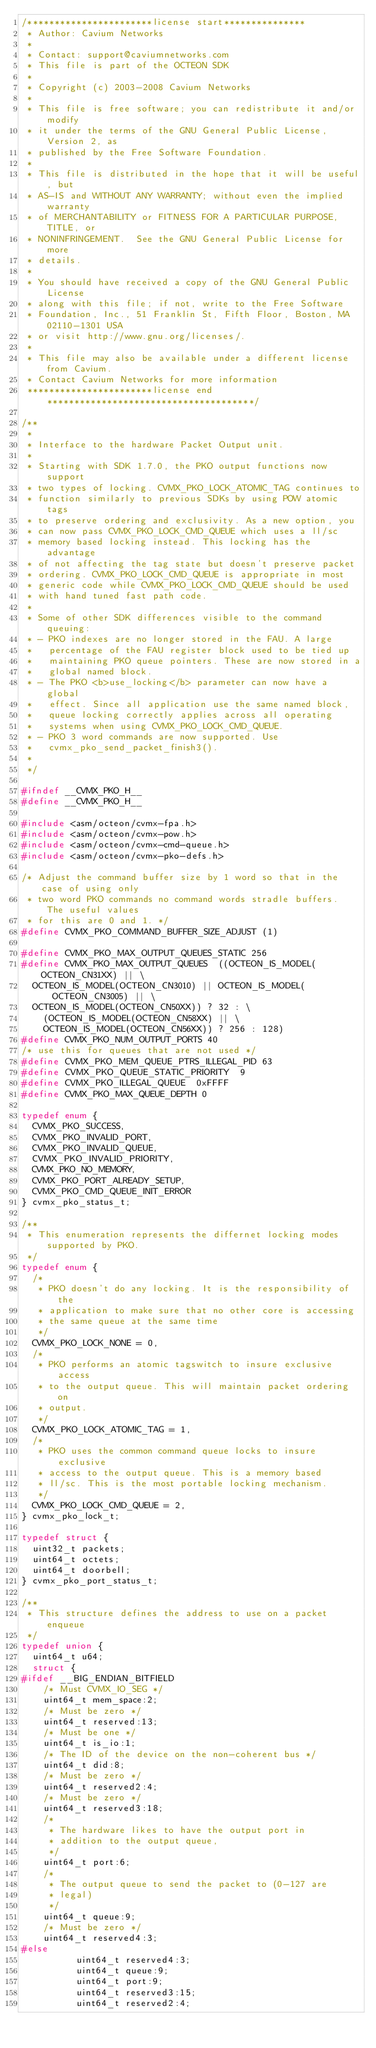<code> <loc_0><loc_0><loc_500><loc_500><_C_>/***********************license start***************
 * Author: Cavium Networks
 *
 * Contact: support@caviumnetworks.com
 * This file is part of the OCTEON SDK
 *
 * Copyright (c) 2003-2008 Cavium Networks
 *
 * This file is free software; you can redistribute it and/or modify
 * it under the terms of the GNU General Public License, Version 2, as
 * published by the Free Software Foundation.
 *
 * This file is distributed in the hope that it will be useful, but
 * AS-IS and WITHOUT ANY WARRANTY; without even the implied warranty
 * of MERCHANTABILITY or FITNESS FOR A PARTICULAR PURPOSE, TITLE, or
 * NONINFRINGEMENT.  See the GNU General Public License for more
 * details.
 *
 * You should have received a copy of the GNU General Public License
 * along with this file; if not, write to the Free Software
 * Foundation, Inc., 51 Franklin St, Fifth Floor, Boston, MA 02110-1301 USA
 * or visit http://www.gnu.org/licenses/.
 *
 * This file may also be available under a different license from Cavium.
 * Contact Cavium Networks for more information
 ***********************license end**************************************/

/**
 *
 * Interface to the hardware Packet Output unit.
 *
 * Starting with SDK 1.7.0, the PKO output functions now support
 * two types of locking. CVMX_PKO_LOCK_ATOMIC_TAG continues to
 * function similarly to previous SDKs by using POW atomic tags
 * to preserve ordering and exclusivity. As a new option, you
 * can now pass CVMX_PKO_LOCK_CMD_QUEUE which uses a ll/sc
 * memory based locking instead. This locking has the advantage
 * of not affecting the tag state but doesn't preserve packet
 * ordering. CVMX_PKO_LOCK_CMD_QUEUE is appropriate in most
 * generic code while CVMX_PKO_LOCK_CMD_QUEUE should be used
 * with hand tuned fast path code.
 *
 * Some of other SDK differences visible to the command queuing:
 * - PKO indexes are no longer stored in the FAU. A large
 *   percentage of the FAU register block used to be tied up
 *   maintaining PKO queue pointers. These are now stored in a
 *   global named block.
 * - The PKO <b>use_locking</b> parameter can now have a global
 *   effect. Since all application use the same named block,
 *   queue locking correctly applies across all operating
 *   systems when using CVMX_PKO_LOCK_CMD_QUEUE.
 * - PKO 3 word commands are now supported. Use
 *   cvmx_pko_send_packet_finish3().
 *
 */

#ifndef __CVMX_PKO_H__
#define __CVMX_PKO_H__

#include <asm/octeon/cvmx-fpa.h>
#include <asm/octeon/cvmx-pow.h>
#include <asm/octeon/cvmx-cmd-queue.h>
#include <asm/octeon/cvmx-pko-defs.h>

/* Adjust the command buffer size by 1 word so that in the case of using only
 * two word PKO commands no command words stradle buffers.  The useful values
 * for this are 0 and 1. */
#define CVMX_PKO_COMMAND_BUFFER_SIZE_ADJUST (1)

#define CVMX_PKO_MAX_OUTPUT_QUEUES_STATIC 256
#define CVMX_PKO_MAX_OUTPUT_QUEUES	((OCTEON_IS_MODEL(OCTEON_CN31XX) || \
	OCTEON_IS_MODEL(OCTEON_CN3010) || OCTEON_IS_MODEL(OCTEON_CN3005) || \
	OCTEON_IS_MODEL(OCTEON_CN50XX)) ? 32 : \
		(OCTEON_IS_MODEL(OCTEON_CN58XX) || \
		OCTEON_IS_MODEL(OCTEON_CN56XX)) ? 256 : 128)
#define CVMX_PKO_NUM_OUTPUT_PORTS	40
/* use this for queues that are not used */
#define CVMX_PKO_MEM_QUEUE_PTRS_ILLEGAL_PID 63
#define CVMX_PKO_QUEUE_STATIC_PRIORITY	9
#define CVMX_PKO_ILLEGAL_QUEUE	0xFFFF
#define CVMX_PKO_MAX_QUEUE_DEPTH 0

typedef enum {
	CVMX_PKO_SUCCESS,
	CVMX_PKO_INVALID_PORT,
	CVMX_PKO_INVALID_QUEUE,
	CVMX_PKO_INVALID_PRIORITY,
	CVMX_PKO_NO_MEMORY,
	CVMX_PKO_PORT_ALREADY_SETUP,
	CVMX_PKO_CMD_QUEUE_INIT_ERROR
} cvmx_pko_status_t;

/**
 * This enumeration represents the differnet locking modes supported by PKO.
 */
typedef enum {
	/*
	 * PKO doesn't do any locking. It is the responsibility of the
	 * application to make sure that no other core is accessing
	 * the same queue at the same time
	 */
	CVMX_PKO_LOCK_NONE = 0,
	/*
	 * PKO performs an atomic tagswitch to insure exclusive access
	 * to the output queue. This will maintain packet ordering on
	 * output.
	 */
	CVMX_PKO_LOCK_ATOMIC_TAG = 1,
	/*
	 * PKO uses the common command queue locks to insure exclusive
	 * access to the output queue. This is a memory based
	 * ll/sc. This is the most portable locking mechanism.
	 */
	CVMX_PKO_LOCK_CMD_QUEUE = 2,
} cvmx_pko_lock_t;

typedef struct {
	uint32_t packets;
	uint64_t octets;
	uint64_t doorbell;
} cvmx_pko_port_status_t;

/**
 * This structure defines the address to use on a packet enqueue
 */
typedef union {
	uint64_t u64;
	struct {
#ifdef __BIG_ENDIAN_BITFIELD
		/* Must CVMX_IO_SEG */
		uint64_t mem_space:2;
		/* Must be zero */
		uint64_t reserved:13;
		/* Must be one */
		uint64_t is_io:1;
		/* The ID of the device on the non-coherent bus */
		uint64_t did:8;
		/* Must be zero */
		uint64_t reserved2:4;
		/* Must be zero */
		uint64_t reserved3:18;
		/*
		 * The hardware likes to have the output port in
		 * addition to the output queue,
		 */
		uint64_t port:6;
		/*
		 * The output queue to send the packet to (0-127 are
		 * legal)
		 */
		uint64_t queue:9;
		/* Must be zero */
		uint64_t reserved4:3;
#else
	        uint64_t reserved4:3;
	        uint64_t queue:9;
	        uint64_t port:9;
	        uint64_t reserved3:15;
	        uint64_t reserved2:4;</code> 